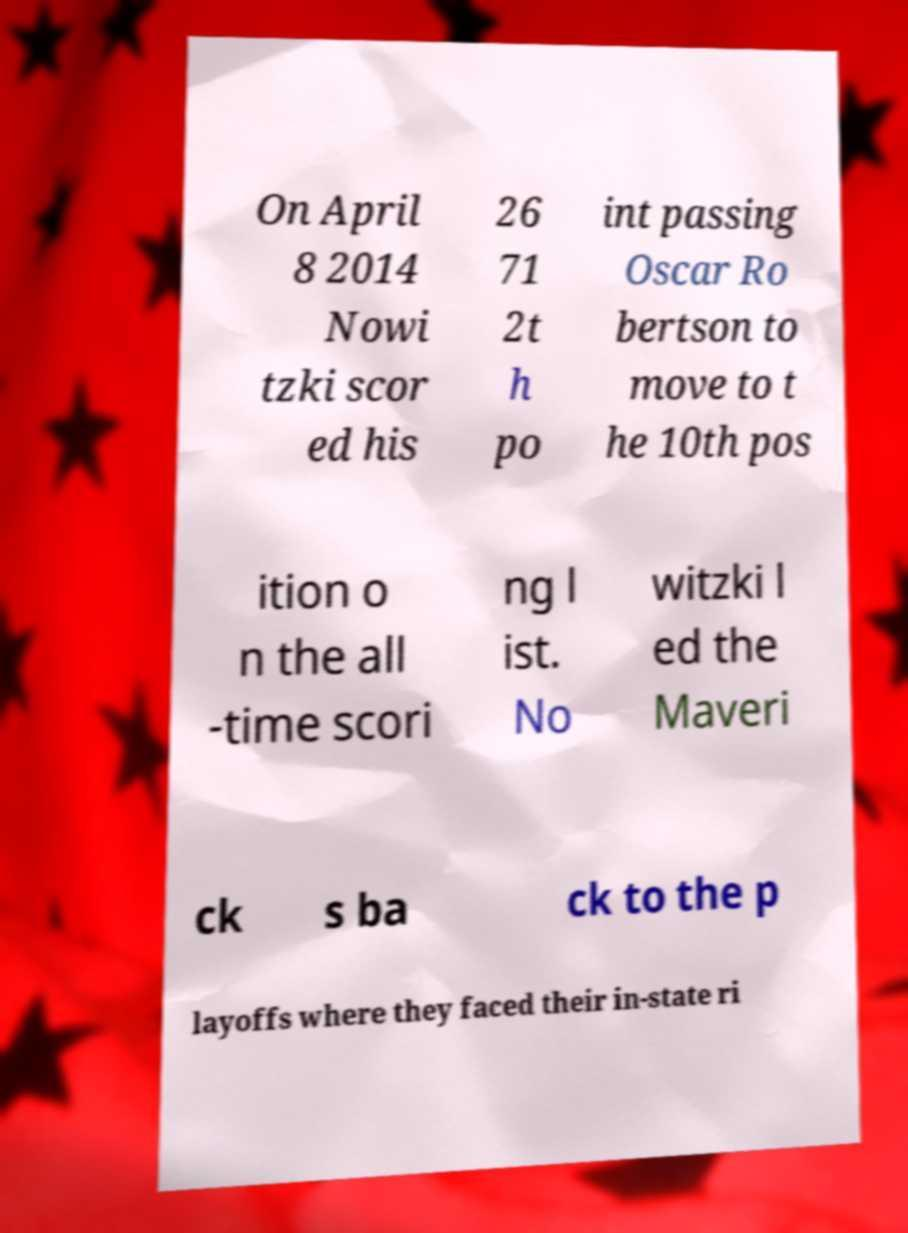I need the written content from this picture converted into text. Can you do that? On April 8 2014 Nowi tzki scor ed his 26 71 2t h po int passing Oscar Ro bertson to move to t he 10th pos ition o n the all -time scori ng l ist. No witzki l ed the Maveri ck s ba ck to the p layoffs where they faced their in-state ri 